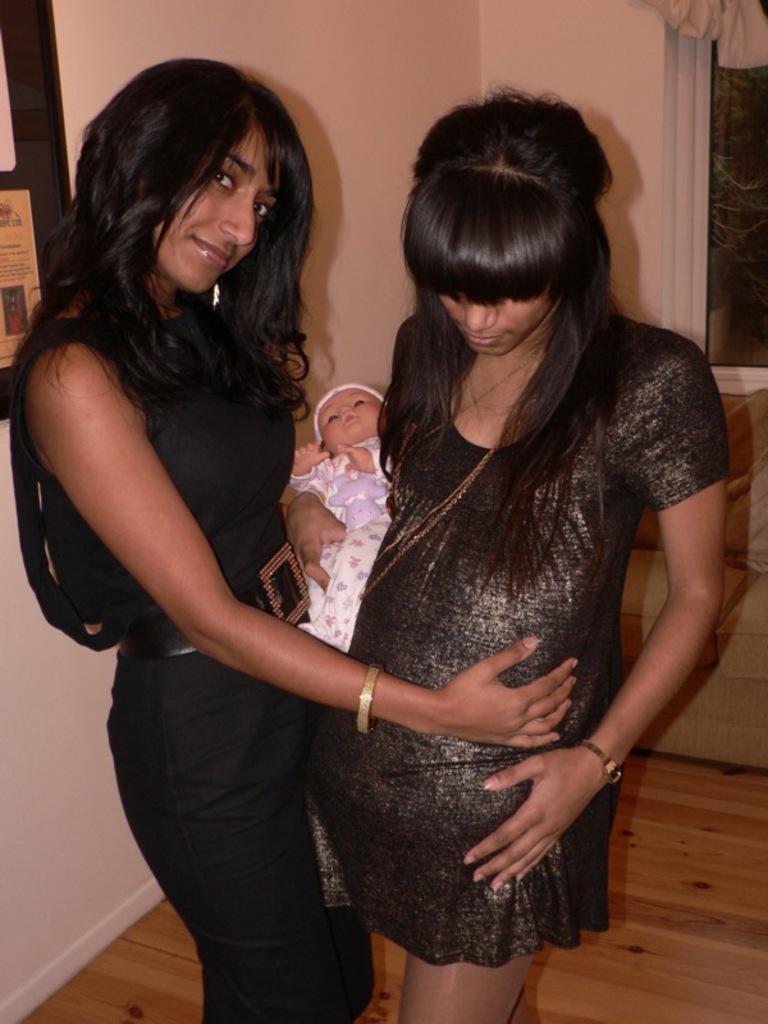How many women are in the image? There are two women in the image. What is the woman in the black dress wearing? The woman in the black dress is wearing a black dress. What is the expression on the woman in the black dress's face? The woman in the black dress is smiling. What is one of the women holding? One of the women is holding a toy. What can be seen in the background of the image? There is a wall in the background of the image. What type of jeans is the woman in the black dress wearing? The woman in the black dress is not wearing jeans; she is wearing a black dress. Can you tell me how many rays are visible in the image? There are no rays visible in the image. 